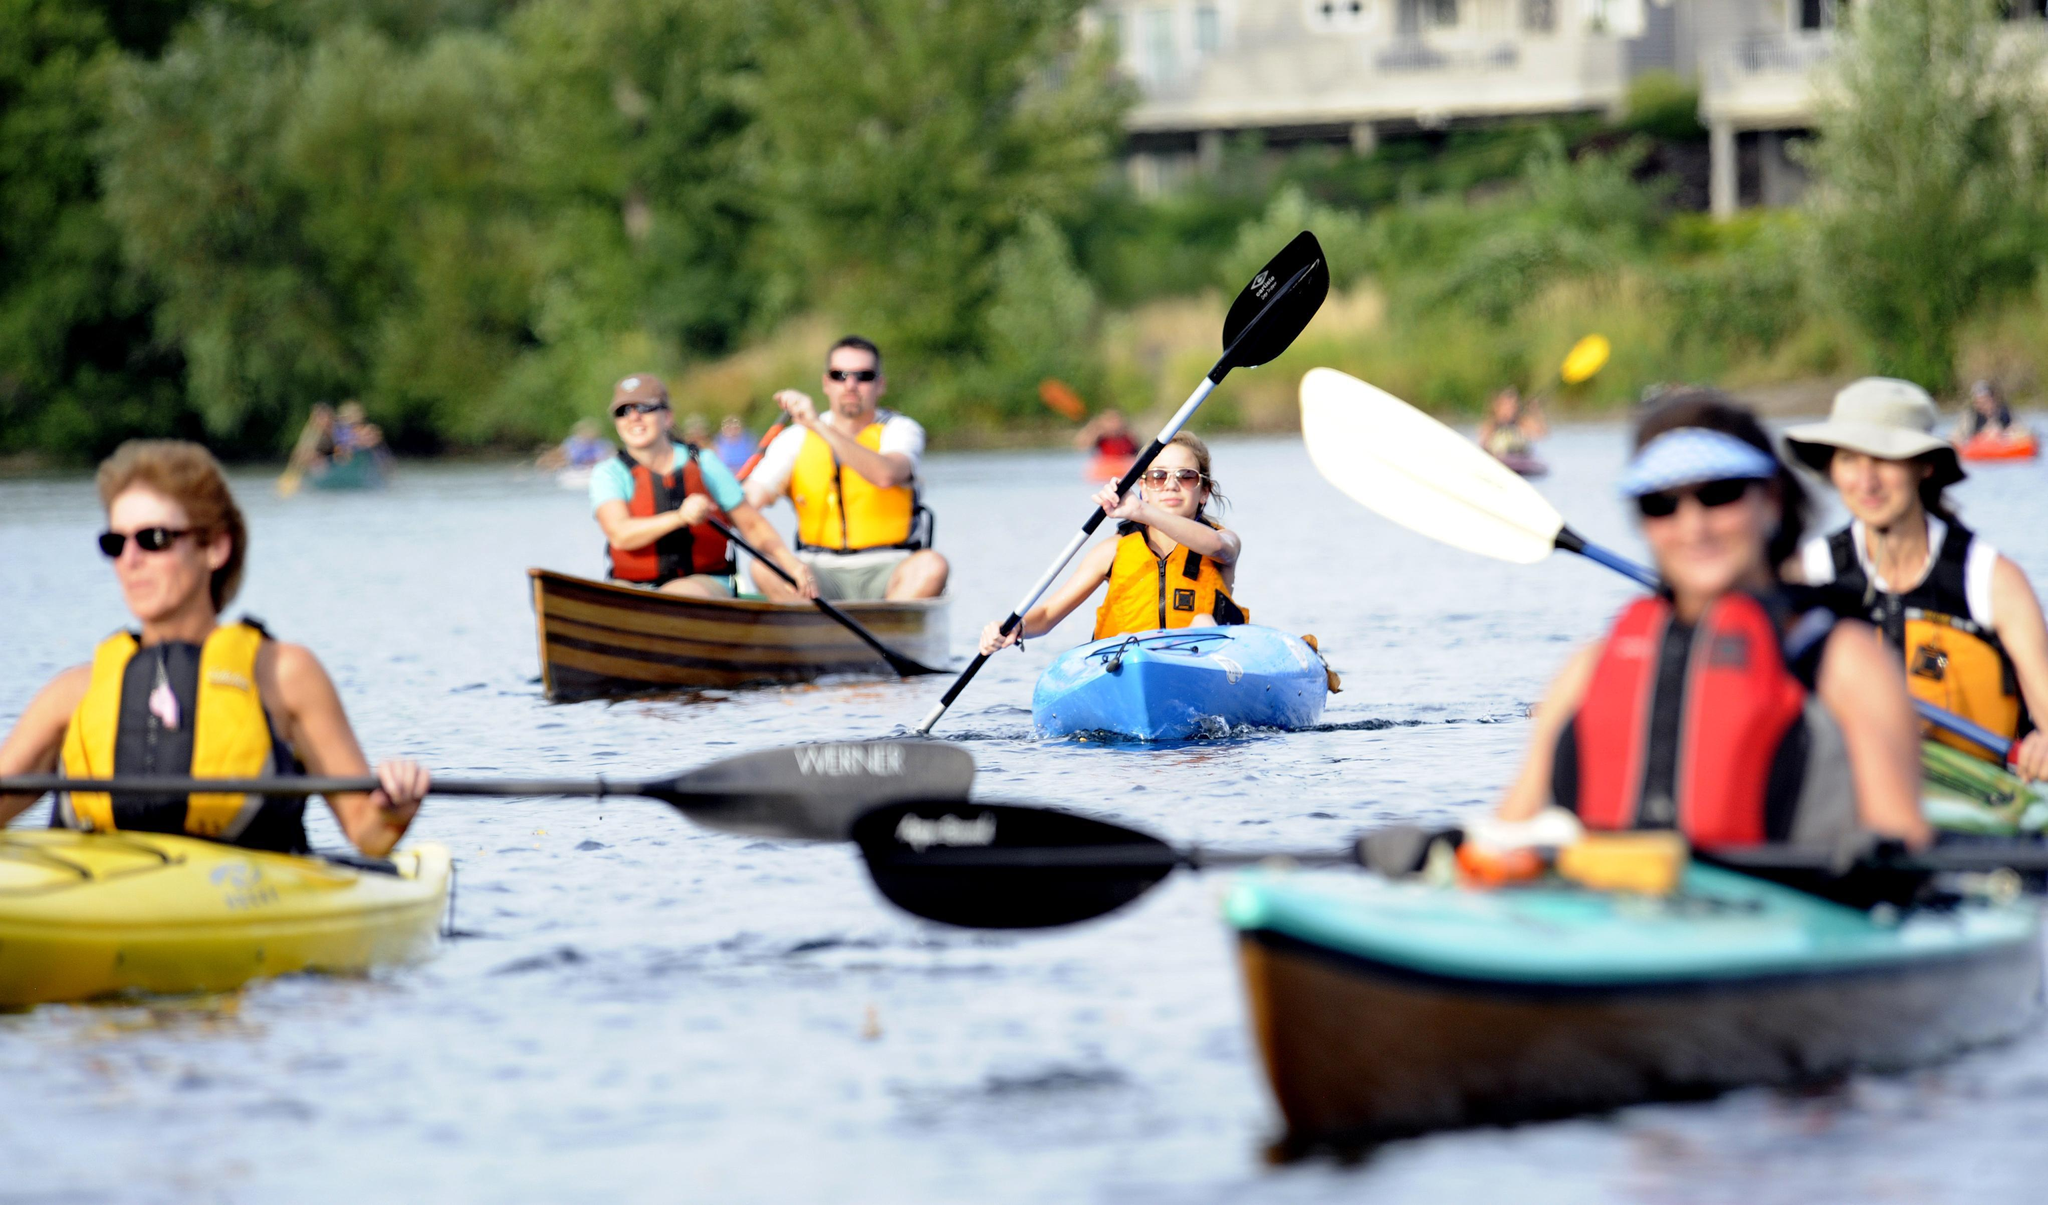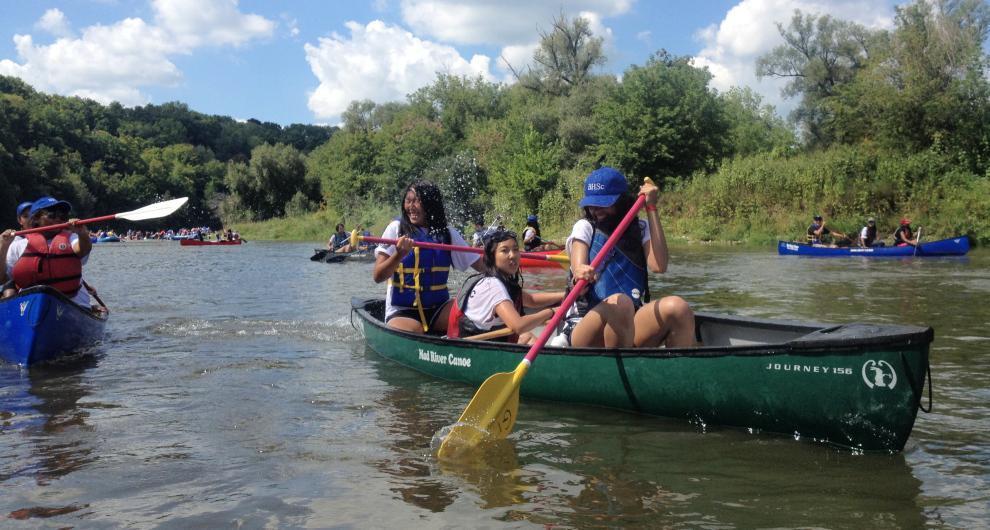The first image is the image on the left, the second image is the image on the right. Analyze the images presented: Is the assertion "The left and right image contains a total of two boats." valid? Answer yes or no. No. The first image is the image on the left, the second image is the image on the right. Analyze the images presented: Is the assertion "The right image shows one canoe, a leftward-headed red canoe with at least three rowers." valid? Answer yes or no. No. 